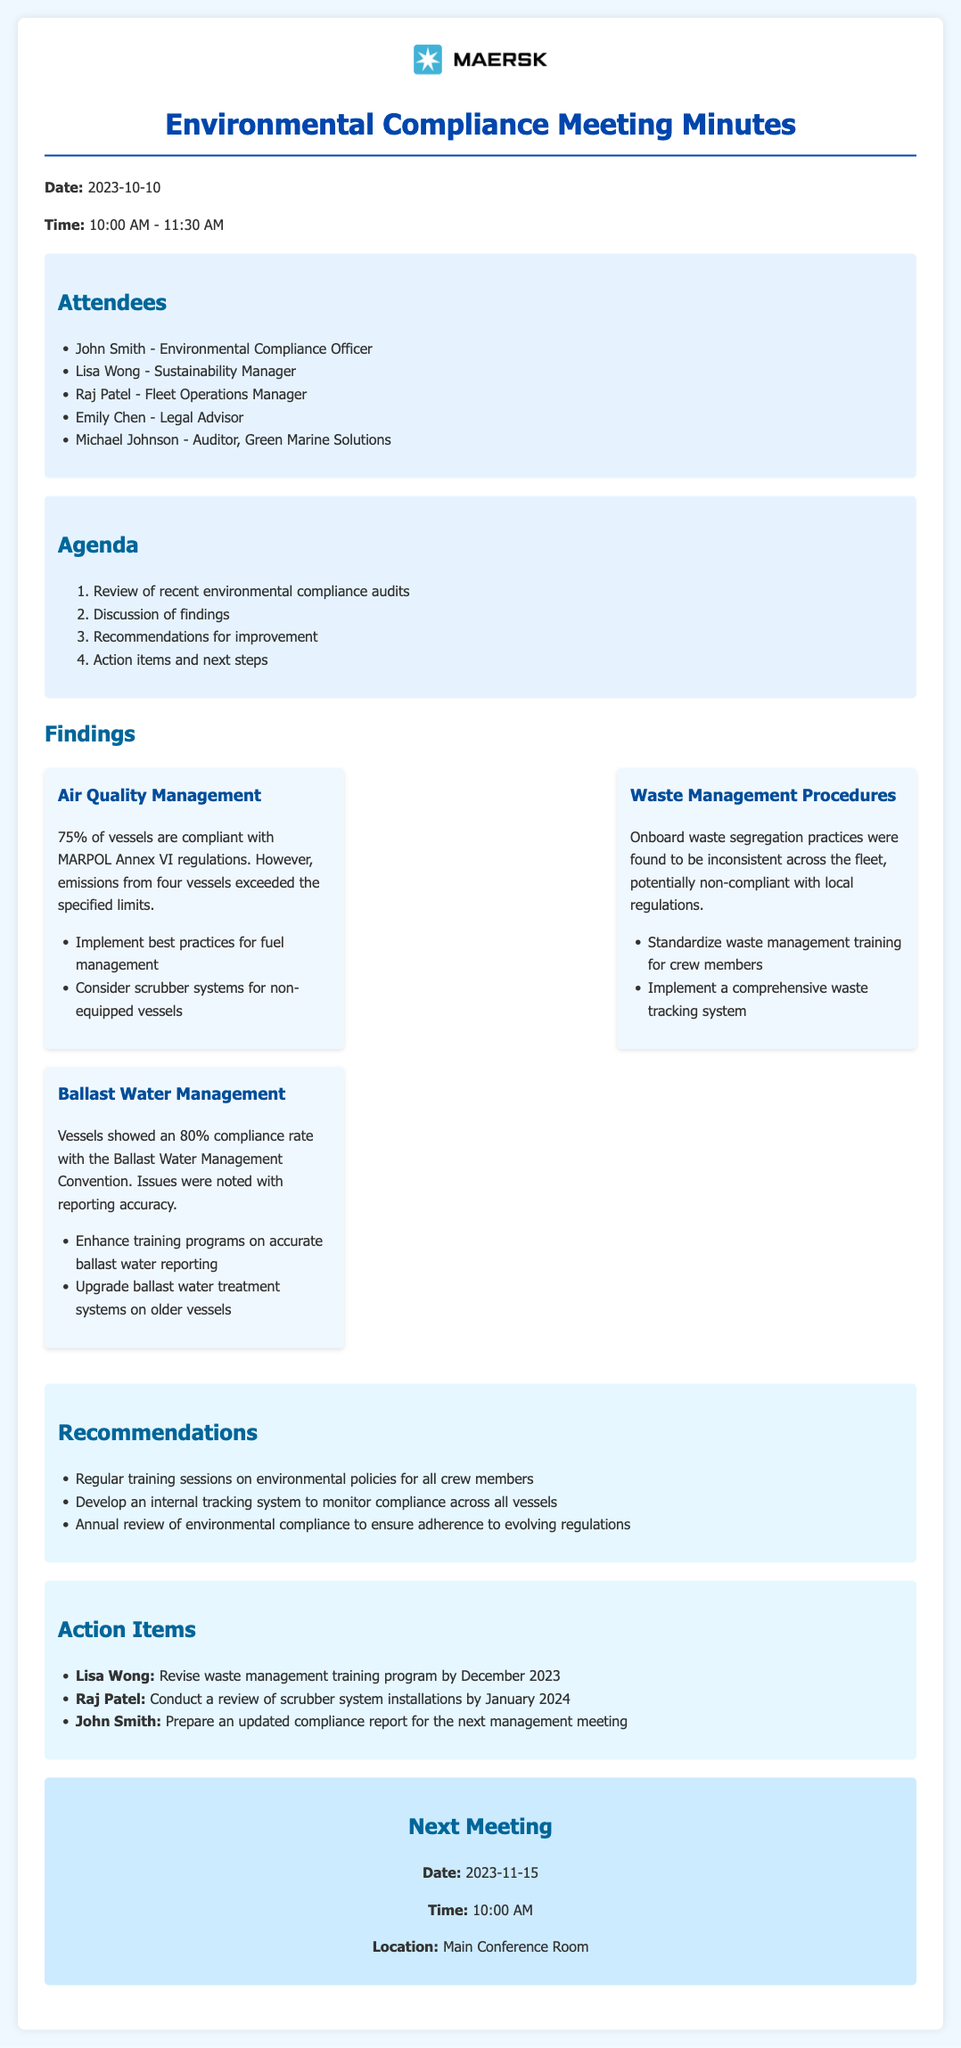what is the date of the meeting? The date of the meeting is clearly stated in the document heading.
Answer: 2023-10-10 who is the Environmental Compliance Officer? The document lists attendees with their respective titles, making it easy to find this information.
Answer: John Smith what percentage of vessels comply with MARPOL Annex VI regulations? The findings section provides specific compliance statistics for air quality management.
Answer: 75% what is one recommendation for improving waste management? The recommendations section outlines several items aimed at enhancing environmental practices, including waste management.
Answer: Standardize waste management training for crew members which section addresses air quality issues? The findings section contains a specific entry about air quality management.
Answer: Air Quality Management how many action items were listed in the document? The action items section contains a list of tasks assigned to individuals, which can be counted.
Answer: 3 what is the compliance rate for ballast water management? The findings for ballast water management provide a specific compliance figure.
Answer: 80% when is the next meeting scheduled? The next meeting section provides the date and time for the upcoming meeting.
Answer: 2023-11-15 what is the time allotted for the meeting? The document specifies the time duration of the meeting within the header section.
Answer: 1.5 hours 